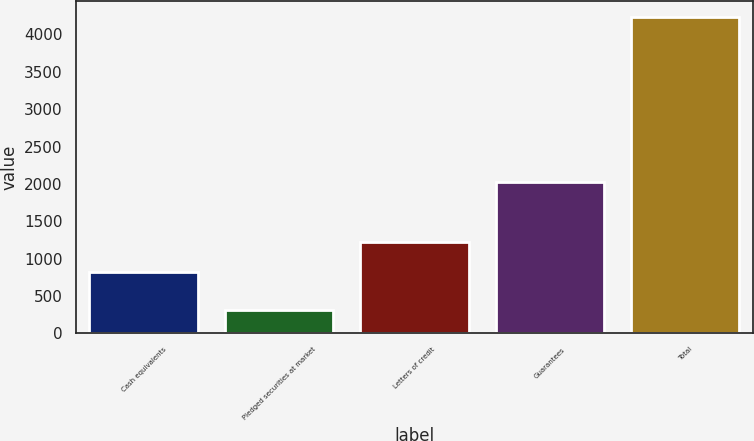Convert chart. <chart><loc_0><loc_0><loc_500><loc_500><bar_chart><fcel>Cash equivalents<fcel>Pledged securities at market<fcel>Letters of credit<fcel>Guarantees<fcel>Total<nl><fcel>823<fcel>307<fcel>1215.9<fcel>2022<fcel>4236<nl></chart> 